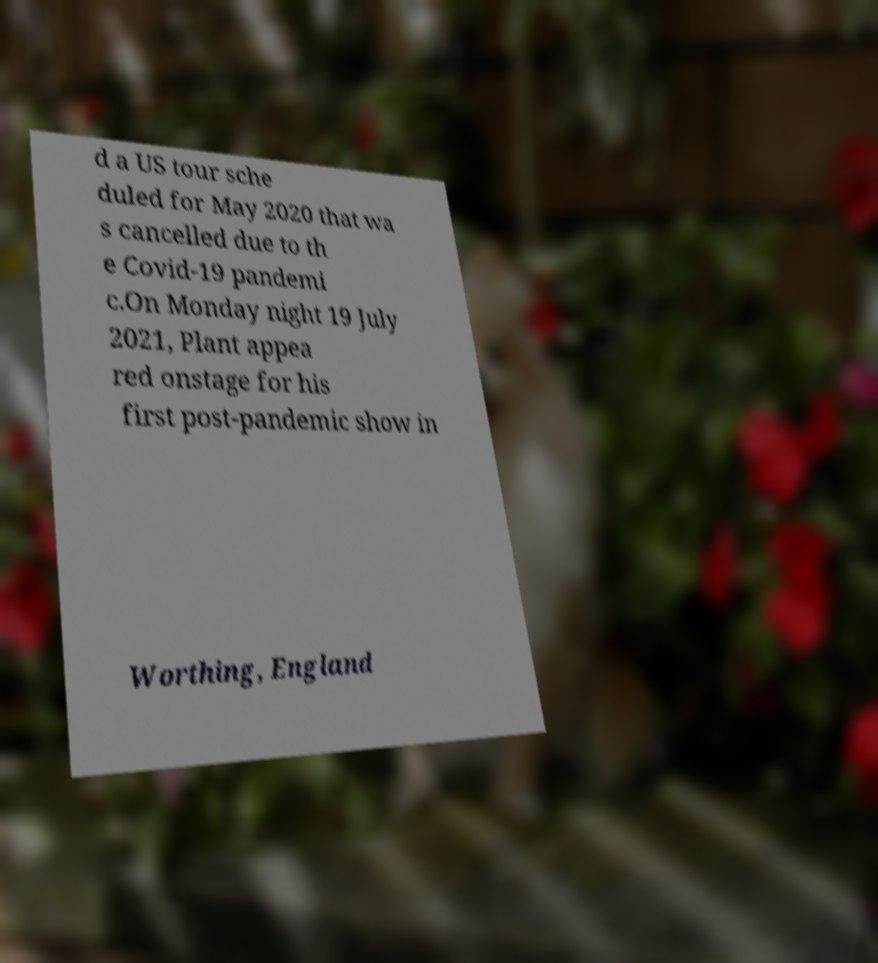What messages or text are displayed in this image? I need them in a readable, typed format. d a US tour sche duled for May 2020 that wa s cancelled due to th e Covid-19 pandemi c.On Monday night 19 July 2021, Plant appea red onstage for his first post-pandemic show in Worthing, England 